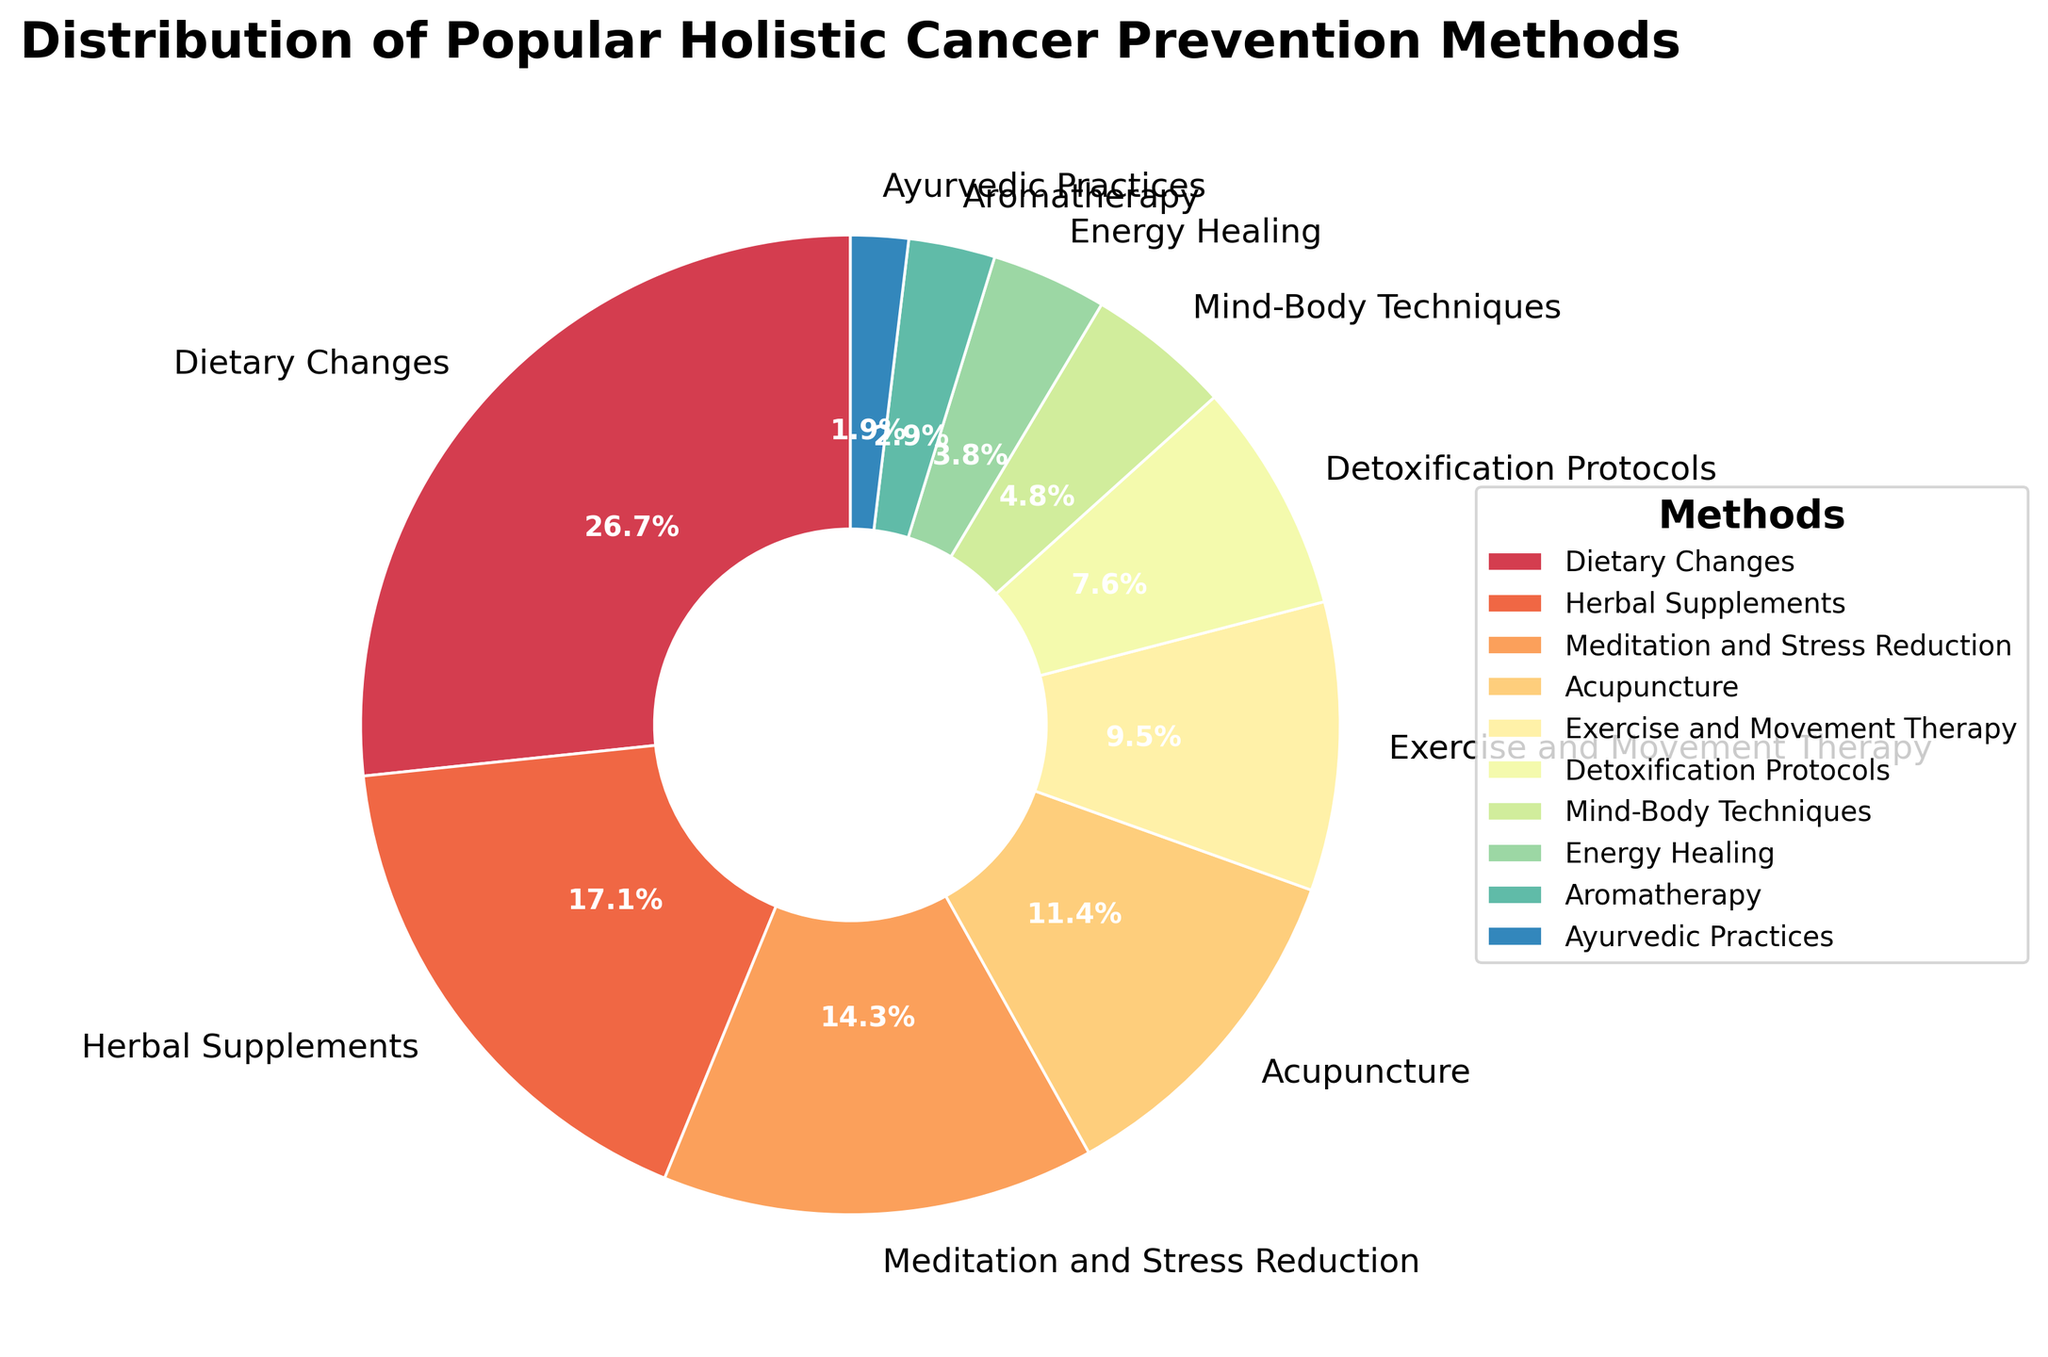What is the most popular holistic cancer prevention method shown in the chart? The figure shows a pie chart that displays different methods and their respective percentages. The segment labeled "Dietary Changes" occupies the largest portion of the chart.
Answer: Dietary Changes Which method has a larger percentage, Herbal Supplements or Acupuncture? By comparing the size of the labeled segments, the "Herbal Supplements" slice is larger than the "Acupuncture" slice. The chart labels show Herbal Supplements at 18% and Acupuncture at 12%.
Answer: Herbal Supplements What is the combined percentage of Meditation and Stress Reduction, and Exercise and Movement Therapy? The pie chart shows Meditation and Stress Reduction at 15% and Exercise and Movement Therapy at 10%. Adding these two percentages together results in 15% + 10% = 25%.
Answer: 25% Among Detoxification Protocols, Mind-Body Techniques, and Energy Healing, which has the smallest percentage? The segments for Detoxification Protocols, Mind-Body Techniques, and Energy Healing are visible in the chart. Detoxification Protocols is labeled at 8%, Mind-Body Techniques at 5%, and Energy Healing at 4%. Energy Healing has the smallest percentage.
Answer: Energy Healing If you combine the percentages of Aromatherapy and Ayurvedic Practices, will it be greater than the percentage of Exercise and Movement Therapy? Aromatherapy is at 3% and Ayurvedic Practices at 2%, giving a combined total of 3% + 2% = 5%. Exercise and Movement Therapy is at 10%, so 5% is less than 10%.
Answer: No Which segment of the pie chart appears to be purple in color? The pie chart uses the Spectral color map, and by observing the colors, the segment that appears purple corresponds to "Detoxification Protocols."
Answer: Detoxification Protocols 